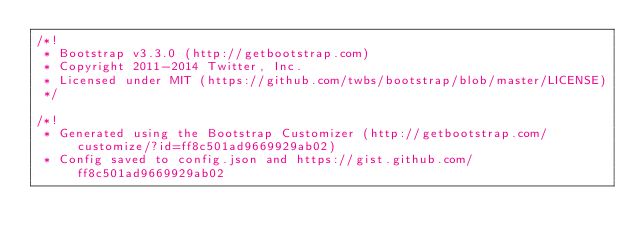<code> <loc_0><loc_0><loc_500><loc_500><_CSS_>/*!
 * Bootstrap v3.3.0 (http://getbootstrap.com)
 * Copyright 2011-2014 Twitter, Inc.
 * Licensed under MIT (https://github.com/twbs/bootstrap/blob/master/LICENSE)
 */

/*!
 * Generated using the Bootstrap Customizer (http://getbootstrap.com/customize/?id=ff8c501ad9669929ab02)
 * Config saved to config.json and https://gist.github.com/ff8c501ad9669929ab02</code> 